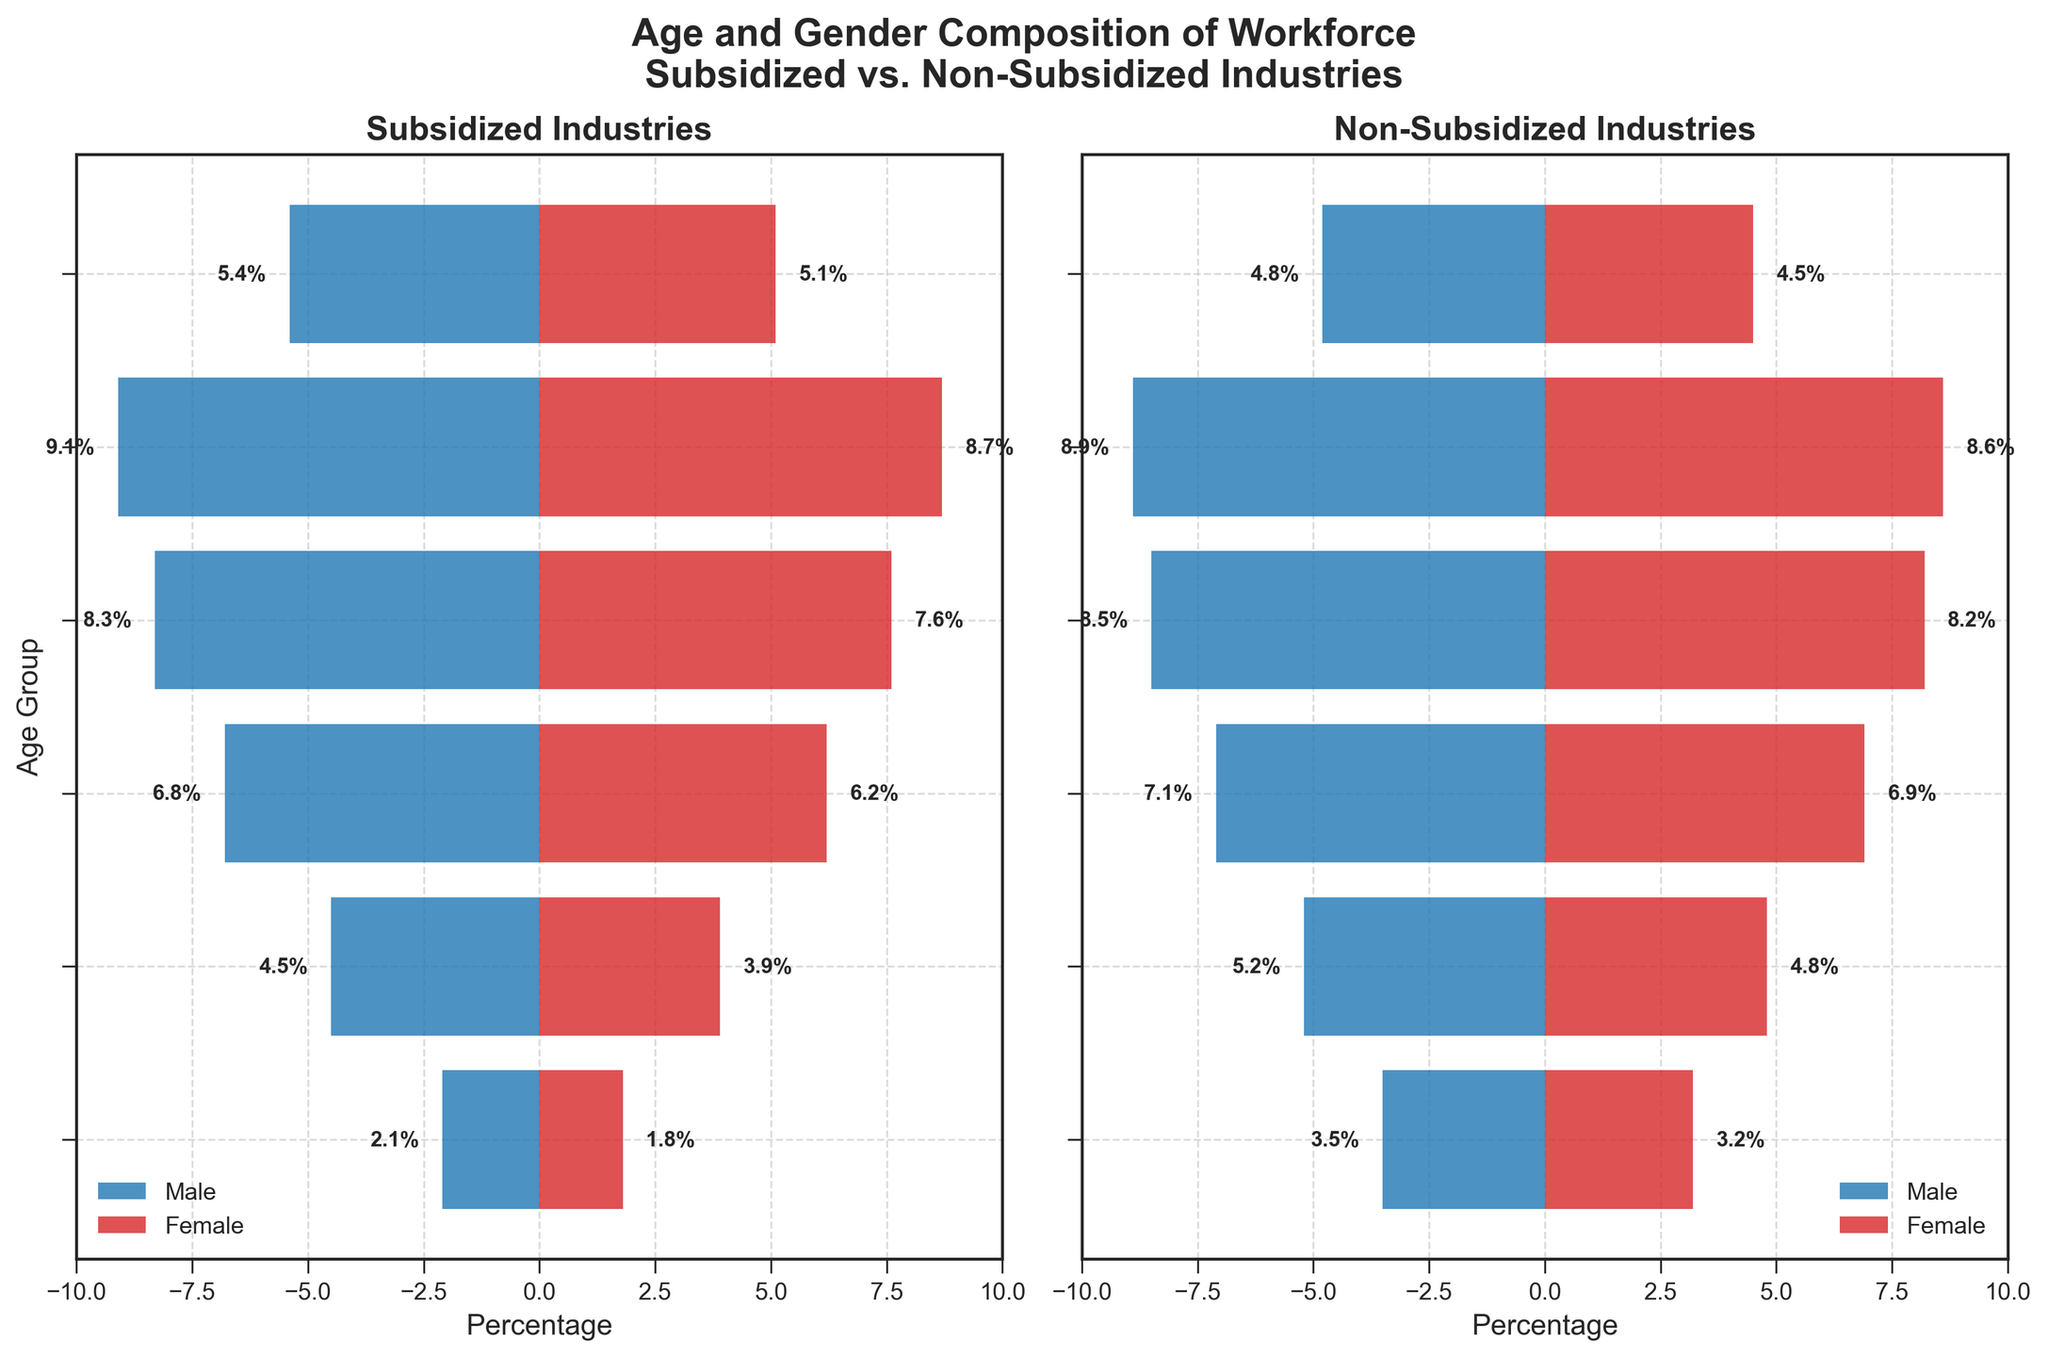What is the title of the figure? The title of the figure is displayed at the top and reads: "Age and Gender Composition of Workforce Subsidized vs. Non-Subsidized Industries".
Answer: Age and Gender Composition of Workforce Subsidized vs. Non-Subsidized Industries Which age group has the highest percentage of workers in both subsidized and non-subsidized industries? To identify the highest percentage of workers, look at the longest bar (either to the left for males or right for females) for each industry. The longest bars are found in the 25-34 age group in both sections of the pyramid, indicating the highest percentage.
Answer: 25-34 How do the percentages of males and females aged 55-64 in non-subsidized industries compare? Locate the 55-64 age category in the non-subsidized industries section. The bars show that 5.2% of males and 4.8% of females fall into this category.
Answer: 5.2% (males), 4.8% (females) What is the percentage difference between males aged 18-24 in subsidized and non-subsidized industries? Find the 18-24 age group for males in both sections. The percentage of males in subsidized industries is 5.4%, and in non-subsidized industries is 4.8%. Subtract the two values to get the difference: 5.4% - 4.8% = 0.6%.
Answer: 0.6% What age group has the smallest percentage of workers in subsidized industries? Identify the shortest bars on both sides of the subsidized section. The 65+ age group has the shortest bars, with percentages of 2.1% (male) and 1.8% (female).
Answer: 65+ Compare the percentage of females aged 25-34 in subsidized versus non-subsidized industries. Look at the 25-34 age group for females in both sections. In subsidized industries, it shows 8.7%, while in non-subsidized industries, it shows 8.6%.
Answer: 8.7%, 8.6% Which age group has more males than females in non-subsidized industries? Check each age group in the non-subsidized industries section to see where the male bar is longer than the female bar. The 18-24 and 25-34 age groups show this slightly but most noticeably in the 18-24 and 55-64 age group.
Answer: 18-24, 55-64 What is the total percentage of workers aged 35-44 in subsidized industries, combining both males and females? Add the percentages of males and females in the 35-44 age group for subsidized industries: 8.3% (male) + 7.6% (female) = 15.9%.
Answer: 15.9% Which gender has a larger share in the 45-54 age group in subsidized industries? For the 45-54 age group in subsidized industries, compare the lengths of the male and female bars. The male bar (6.8%) is slightly longer than the female bar (6.2%), indicating males have a larger share.
Answer: Males Are there more males or females aged 65+ in non-subsidized industries? Assess the 65+ age group in the non-subsidized industries section. The male percentage is 3.5%, and the female percentage is 3.2%. There are more males in this age group.
Answer: Males 